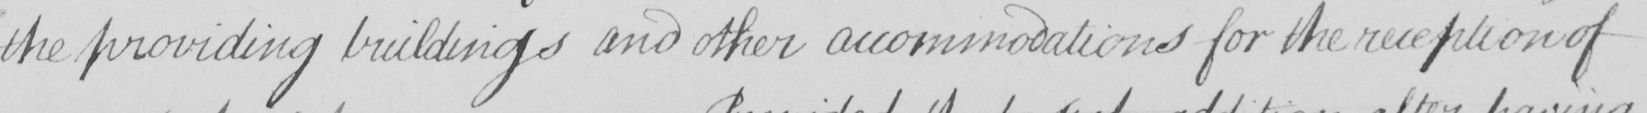What does this handwritten line say? the providing buildings and other accommodations for the reception of 